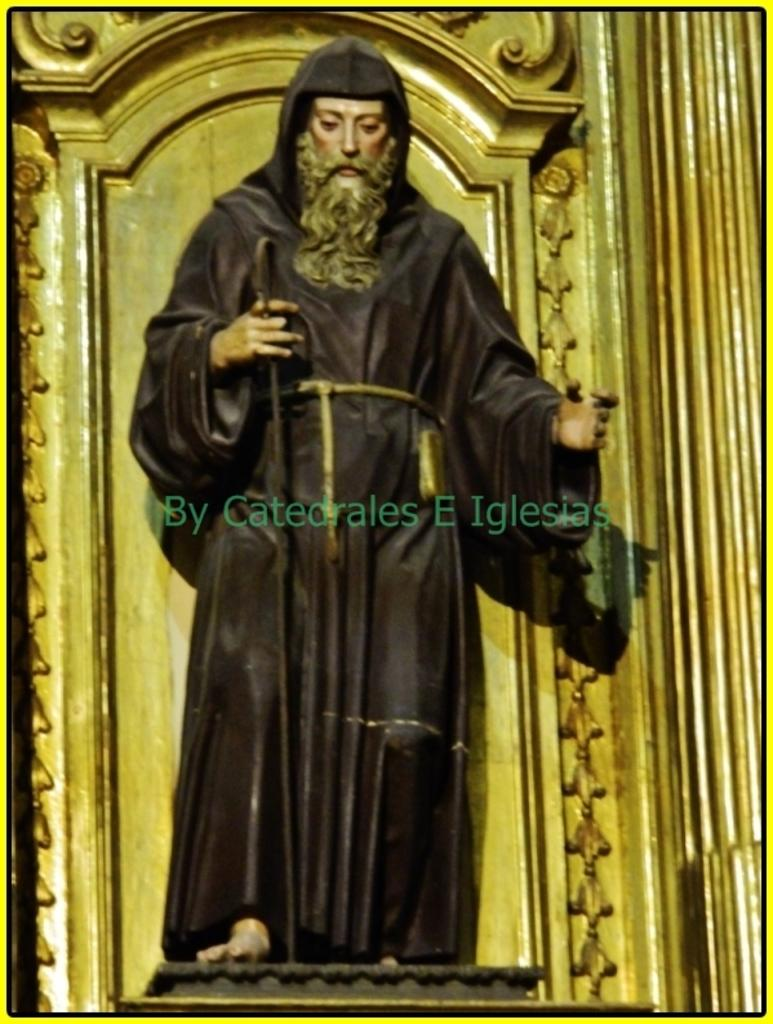What is the main subject in the image? There is a statue in the image. What type of advice does the grandfather give to the spy in the image? There is no grandfather or spy present in the image; it only features a statue. 